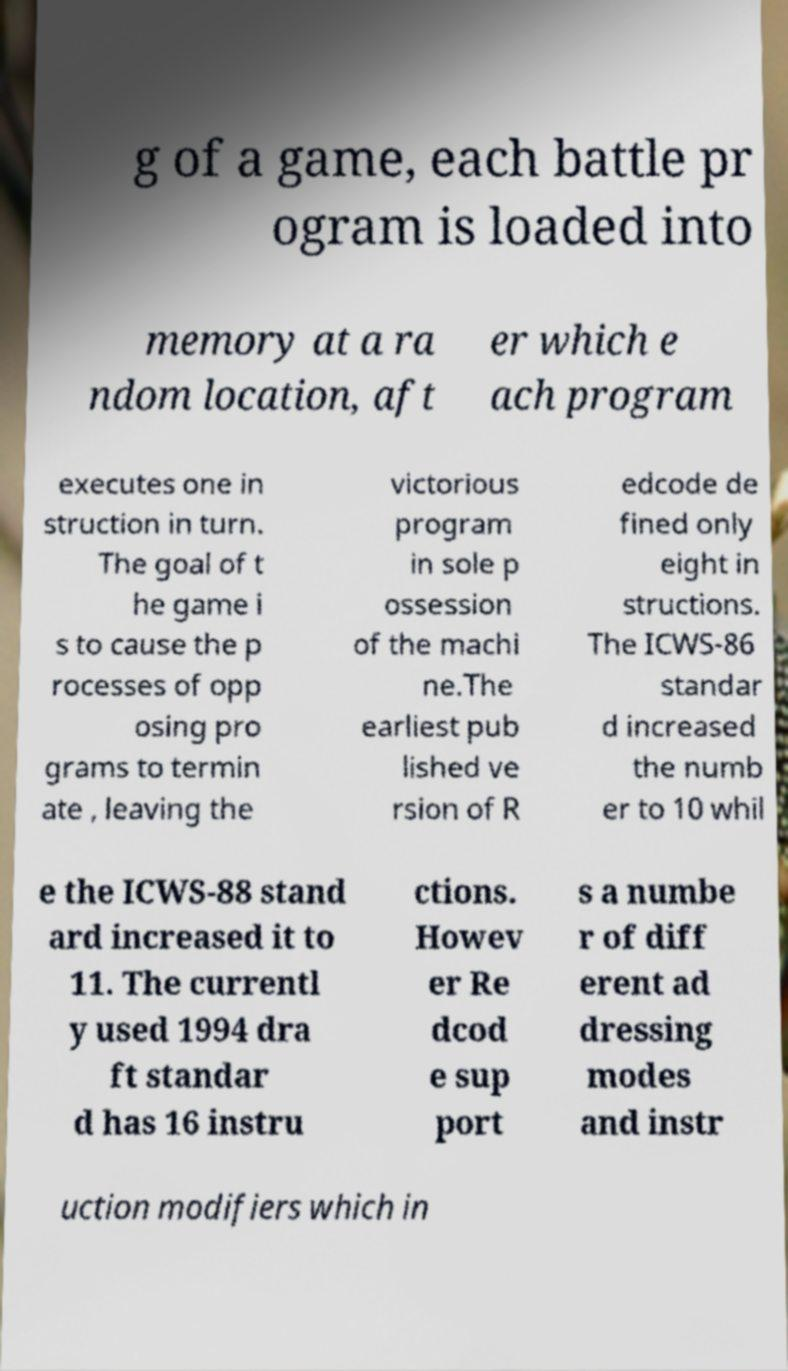Please read and relay the text visible in this image. What does it say? g of a game, each battle pr ogram is loaded into memory at a ra ndom location, aft er which e ach program executes one in struction in turn. The goal of t he game i s to cause the p rocesses of opp osing pro grams to termin ate , leaving the victorious program in sole p ossession of the machi ne.The earliest pub lished ve rsion of R edcode de fined only eight in structions. The ICWS-86 standar d increased the numb er to 10 whil e the ICWS-88 stand ard increased it to 11. The currentl y used 1994 dra ft standar d has 16 instru ctions. Howev er Re dcod e sup port s a numbe r of diff erent ad dressing modes and instr uction modifiers which in 